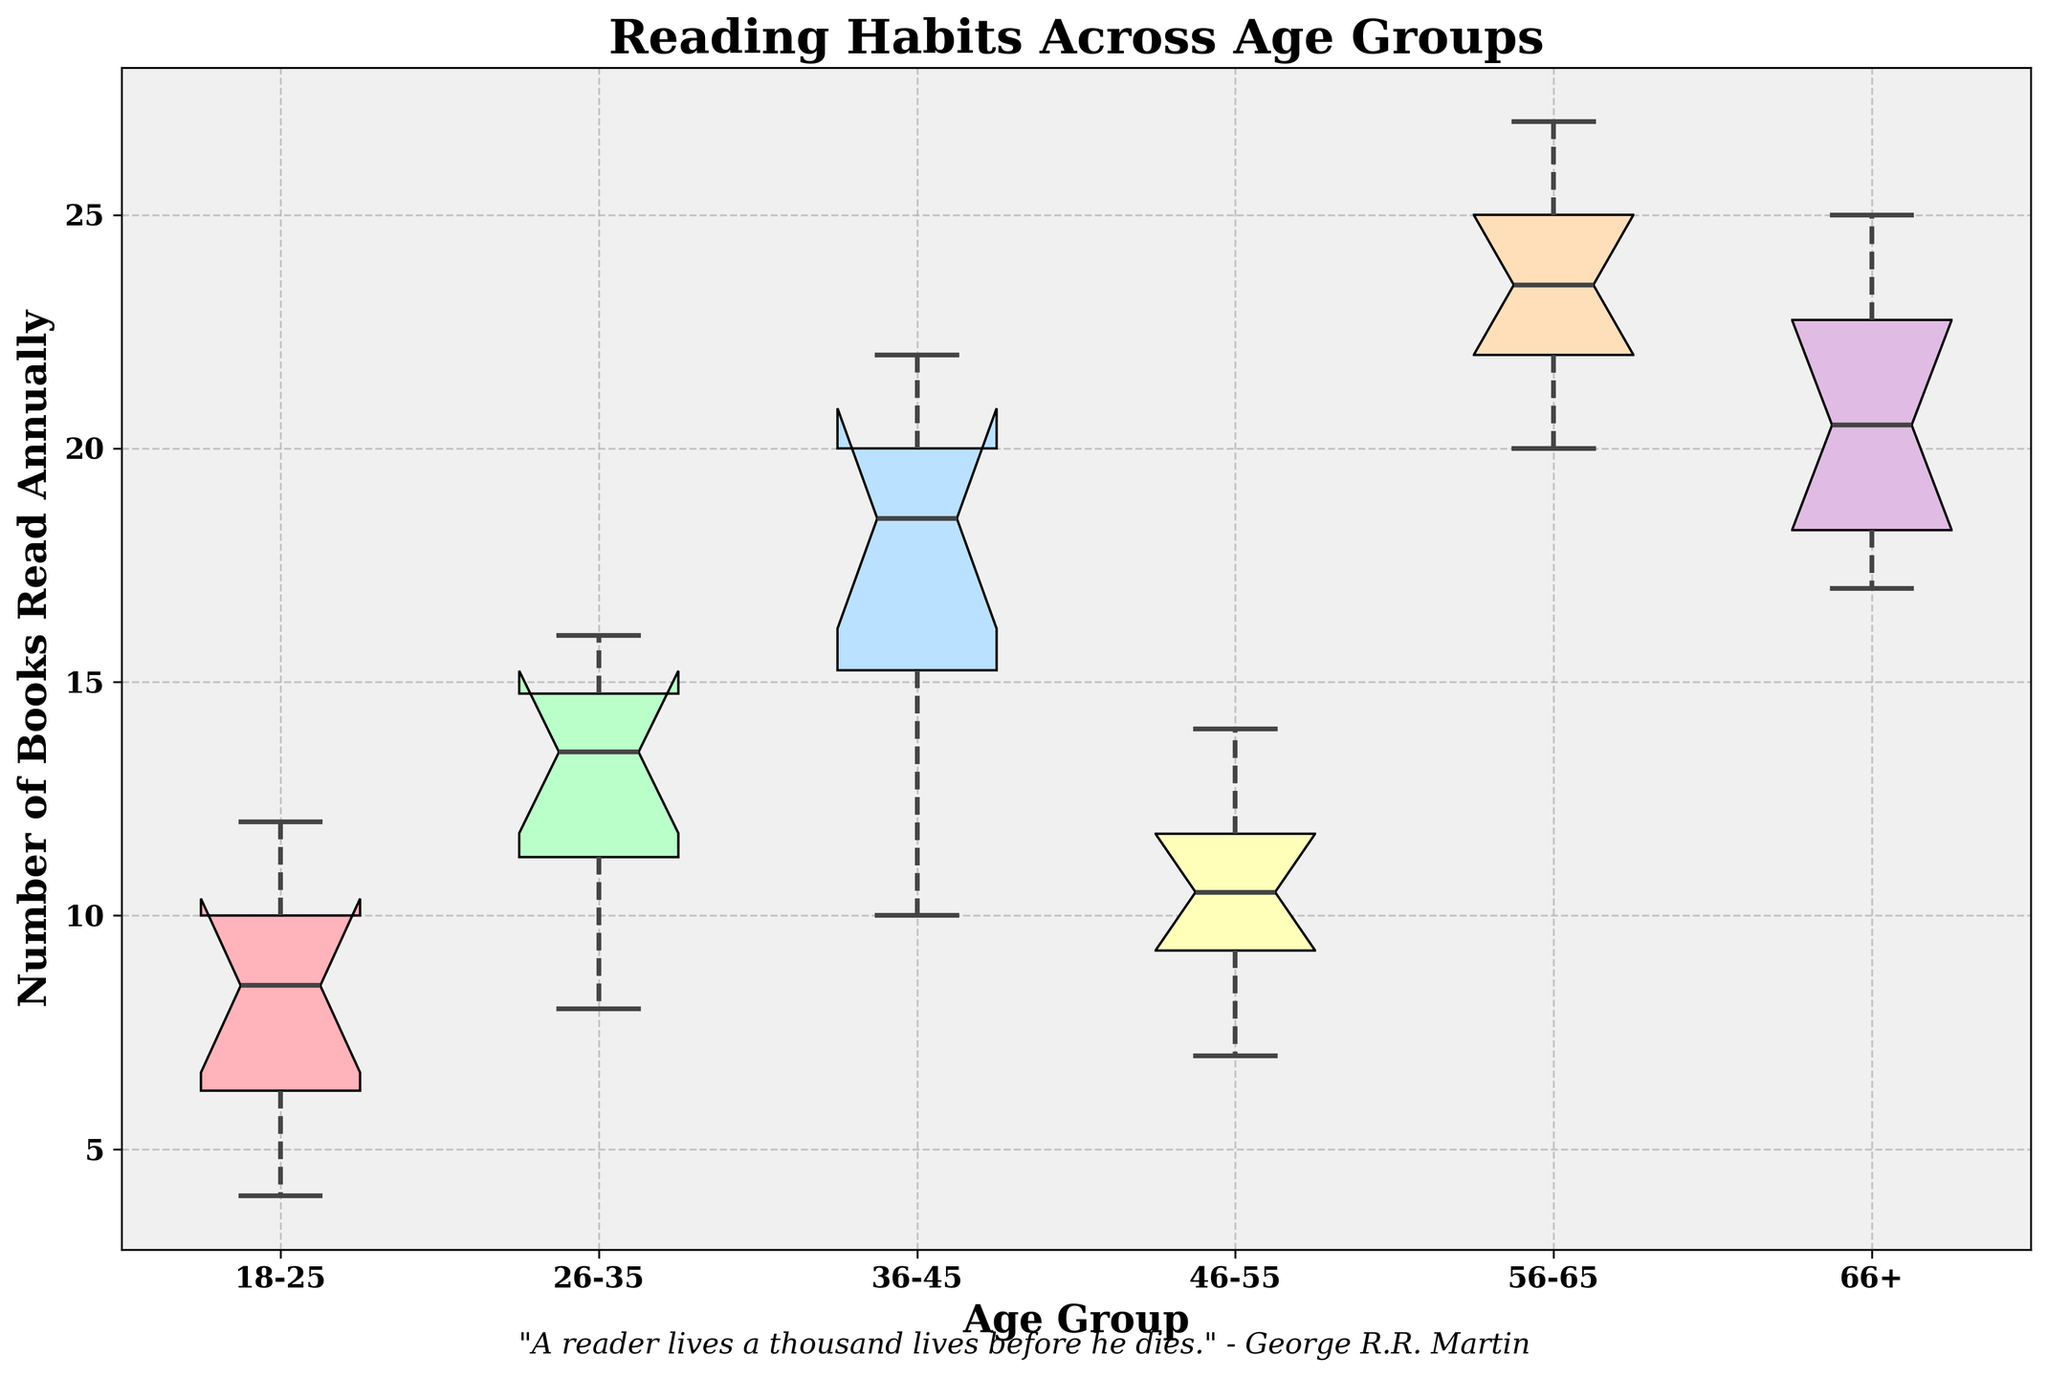What is the title of the plot? The title of the plot is displayed at the top of the figure. It helps to convey the main subject of the visual representation.
Answer: Reading Habits Across Age Groups Which age group has the widest interquartile range (IQR) for the number of books read annually? The interquartile range (IQR) can be determined by looking at the box. The group with the widest box has the widest IQR.
Answer: 56-65 What is the median number of books read annually by the 36-45 age group? The median is represented by the line inside the box of each age group in the notched box plot. The line inside the box for 36-45 will provide the median value.
Answer: 19 Which age group reads the fewest books annually on average? To determine the average number of books read, we need to estimate the central tendency. The group with the lowest median value represents the lowest average reading habits.
Answer: 18-25 Compare the median number of books read annually between the 26-35 and 46-55 age groups. Which group reads more? By comparing the median lines within the boxes of the notched box plot for the 26-35 and 46-55 age groups, we can determine which median value is higher.
Answer: 26-35 What can you infer about the distribution of books read annually among the 56-65 age group based on the notches? The notches give an indication of the variability around the median and whether the medians of different groups are significantly different. If the notches do not overlap, it suggests a significant difference in medians.
Answer: High variability, no overlap with other groups Which group shows the most consistent reading habits? Consistent reading habits can be inferred from the narrowness of the boxes and the short whiskers, indicating lesser variability.
Answer: 18-25 What quote is featured at the bottom of the plot, and who is it attributed to? There's a text line at the bottom of the plot with a quote. It’s usually written in a different style than the main text to make it stand out.
Answer: "A reader lives a thousand lives before he dies." - George R.R. Martin 